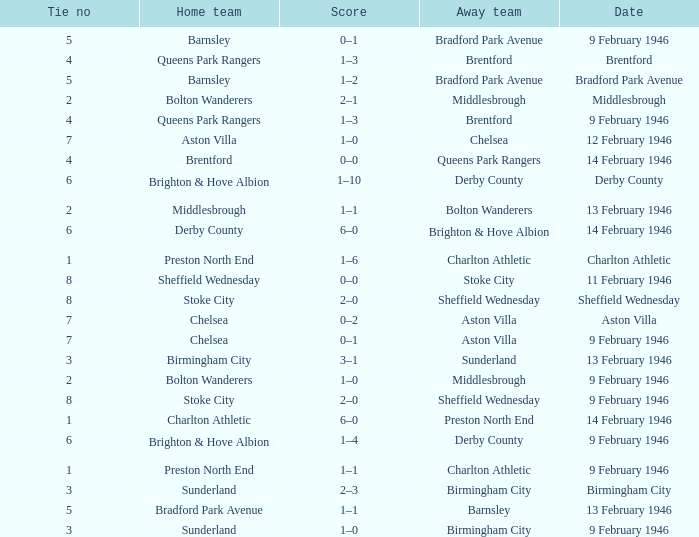Can you parse all the data within this table? {'header': ['Tie no', 'Home team', 'Score', 'Away team', 'Date'], 'rows': [['5', 'Barnsley', '0–1', 'Bradford Park Avenue', '9 February 1946'], ['4', 'Queens Park Rangers', '1–3', 'Brentford', 'Brentford'], ['5', 'Barnsley', '1–2', 'Bradford Park Avenue', 'Bradford Park Avenue'], ['2', 'Bolton Wanderers', '2–1', 'Middlesbrough', 'Middlesbrough'], ['4', 'Queens Park Rangers', '1–3', 'Brentford', '9 February 1946'], ['7', 'Aston Villa', '1–0', 'Chelsea', '12 February 1946'], ['4', 'Brentford', '0–0', 'Queens Park Rangers', '14 February 1946'], ['6', 'Brighton & Hove Albion', '1–10', 'Derby County', 'Derby County'], ['2', 'Middlesbrough', '1–1', 'Bolton Wanderers', '13 February 1946'], ['6', 'Derby County', '6–0', 'Brighton & Hove Albion', '14 February 1946'], ['1', 'Preston North End', '1–6', 'Charlton Athletic', 'Charlton Athletic'], ['8', 'Sheffield Wednesday', '0–0', 'Stoke City', '11 February 1946'], ['8', 'Stoke City', '2–0', 'Sheffield Wednesday', 'Sheffield Wednesday'], ['7', 'Chelsea', '0–2', 'Aston Villa', 'Aston Villa'], ['7', 'Chelsea', '0–1', 'Aston Villa', '9 February 1946'], ['3', 'Birmingham City', '3–1', 'Sunderland', '13 February 1946'], ['2', 'Bolton Wanderers', '1–0', 'Middlesbrough', '9 February 1946'], ['8', 'Stoke City', '2–0', 'Sheffield Wednesday', '9 February 1946'], ['1', 'Charlton Athletic', '6–0', 'Preston North End', '14 February 1946'], ['6', 'Brighton & Hove Albion', '1–4', 'Derby County', '9 February 1946'], ['1', 'Preston North End', '1–1', 'Charlton Athletic', '9 February 1946'], ['3', 'Sunderland', '2–3', 'Birmingham City', 'Birmingham City'], ['5', 'Bradford Park Avenue', '1–1', 'Barnsley', '13 February 1946'], ['3', 'Sunderland', '1–0', 'Birmingham City', '9 February 1946']]} What was the Tie no when then home team was Stoke City for the game played on 9 February 1946? 8.0. 